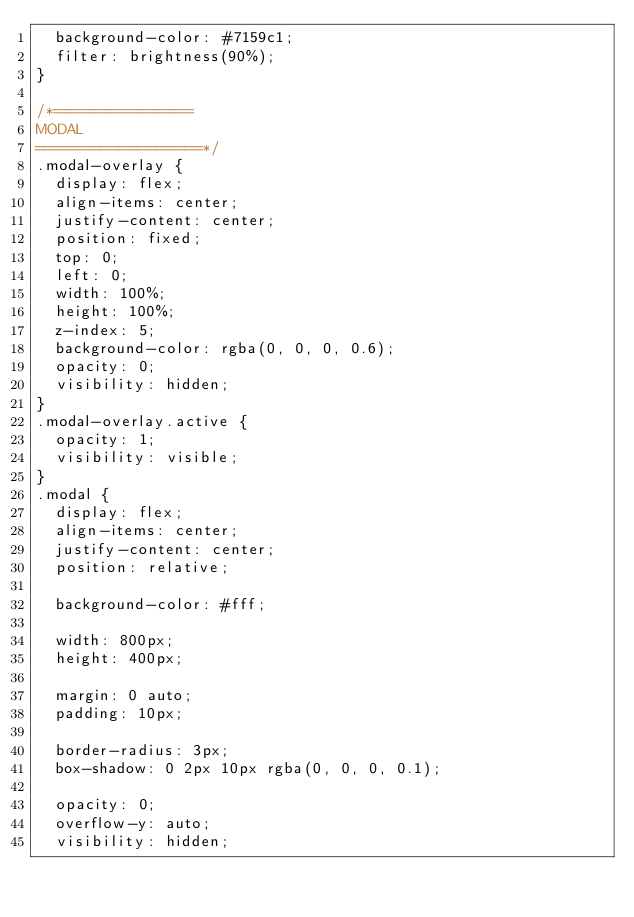Convert code to text. <code><loc_0><loc_0><loc_500><loc_500><_CSS_>  background-color: #7159c1;
  filter: brightness(90%);
}

/*=============== 
MODAL
==================*/
.modal-overlay {
  display: flex;
  align-items: center;
  justify-content: center;
  position: fixed;
  top: 0;
  left: 0;
  width: 100%;
  height: 100%;
  z-index: 5;
  background-color: rgba(0, 0, 0, 0.6);
  opacity: 0;
  visibility: hidden;
}
.modal-overlay.active {
  opacity: 1;
  visibility: visible;
}
.modal {
  display: flex;
  align-items: center;
  justify-content: center;
  position: relative;
  
  background-color: #fff;
  
  width: 800px;
  height: 400px;
  
  margin: 0 auto;
  padding: 10px;
  
  border-radius: 3px;
  box-shadow: 0 2px 10px rgba(0, 0, 0, 0.1);
  
  opacity: 0;
  overflow-y: auto;
  visibility: hidden;
  </code> 